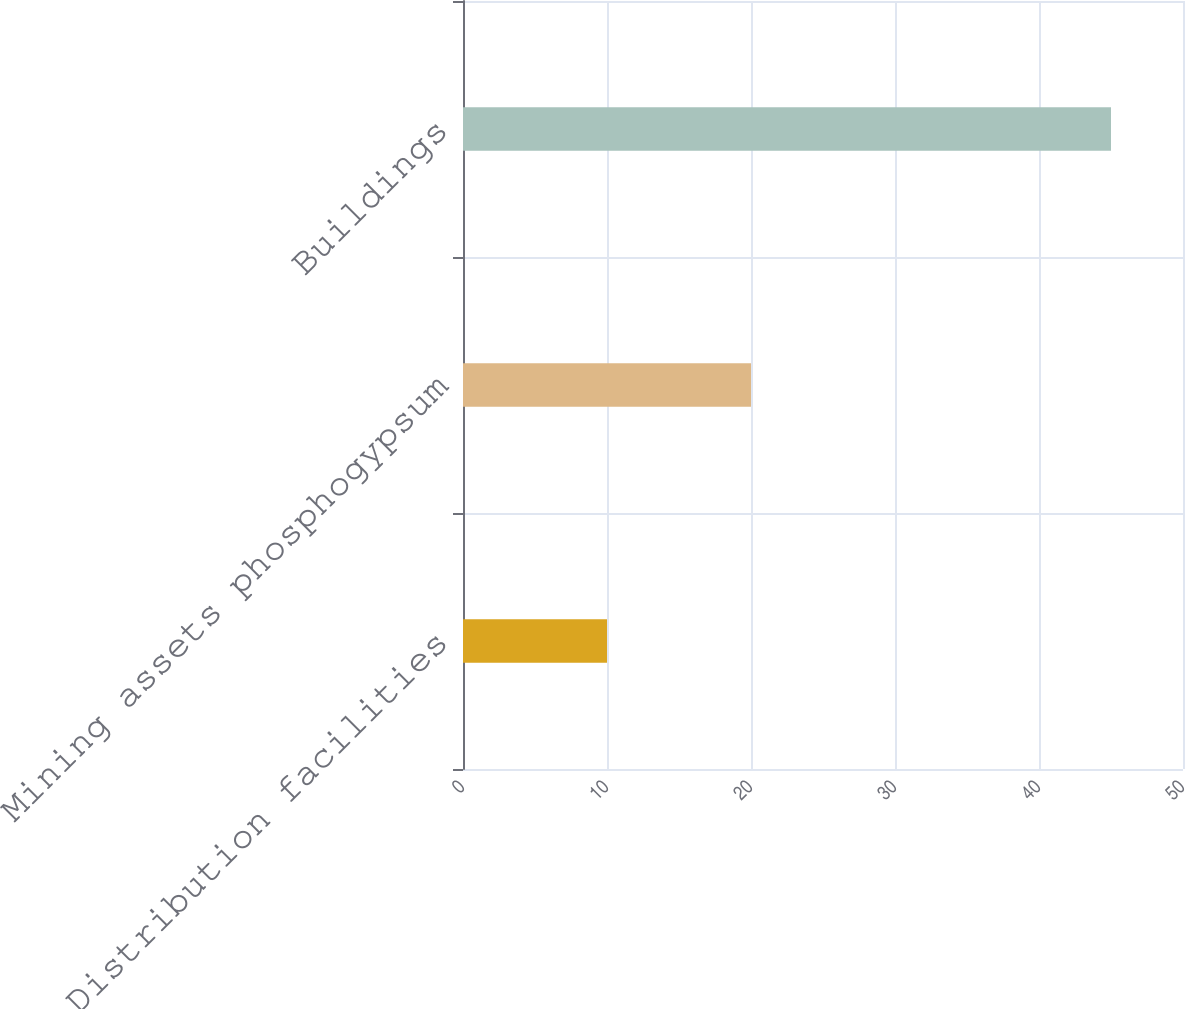Convert chart to OTSL. <chart><loc_0><loc_0><loc_500><loc_500><bar_chart><fcel>Distribution facilities<fcel>Mining assets phosphogypsum<fcel>Buildings<nl><fcel>10<fcel>20<fcel>45<nl></chart> 